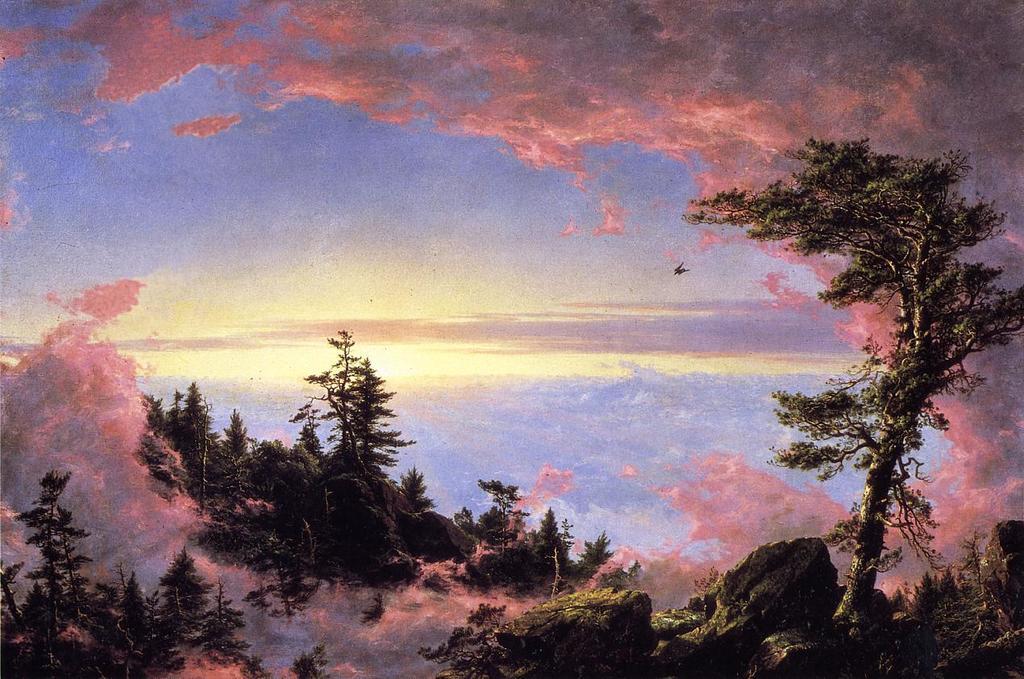Please provide a concise description of this image. In this image, we can see a painting. In this painting, we can see few trees, plants and cloudy sky. 